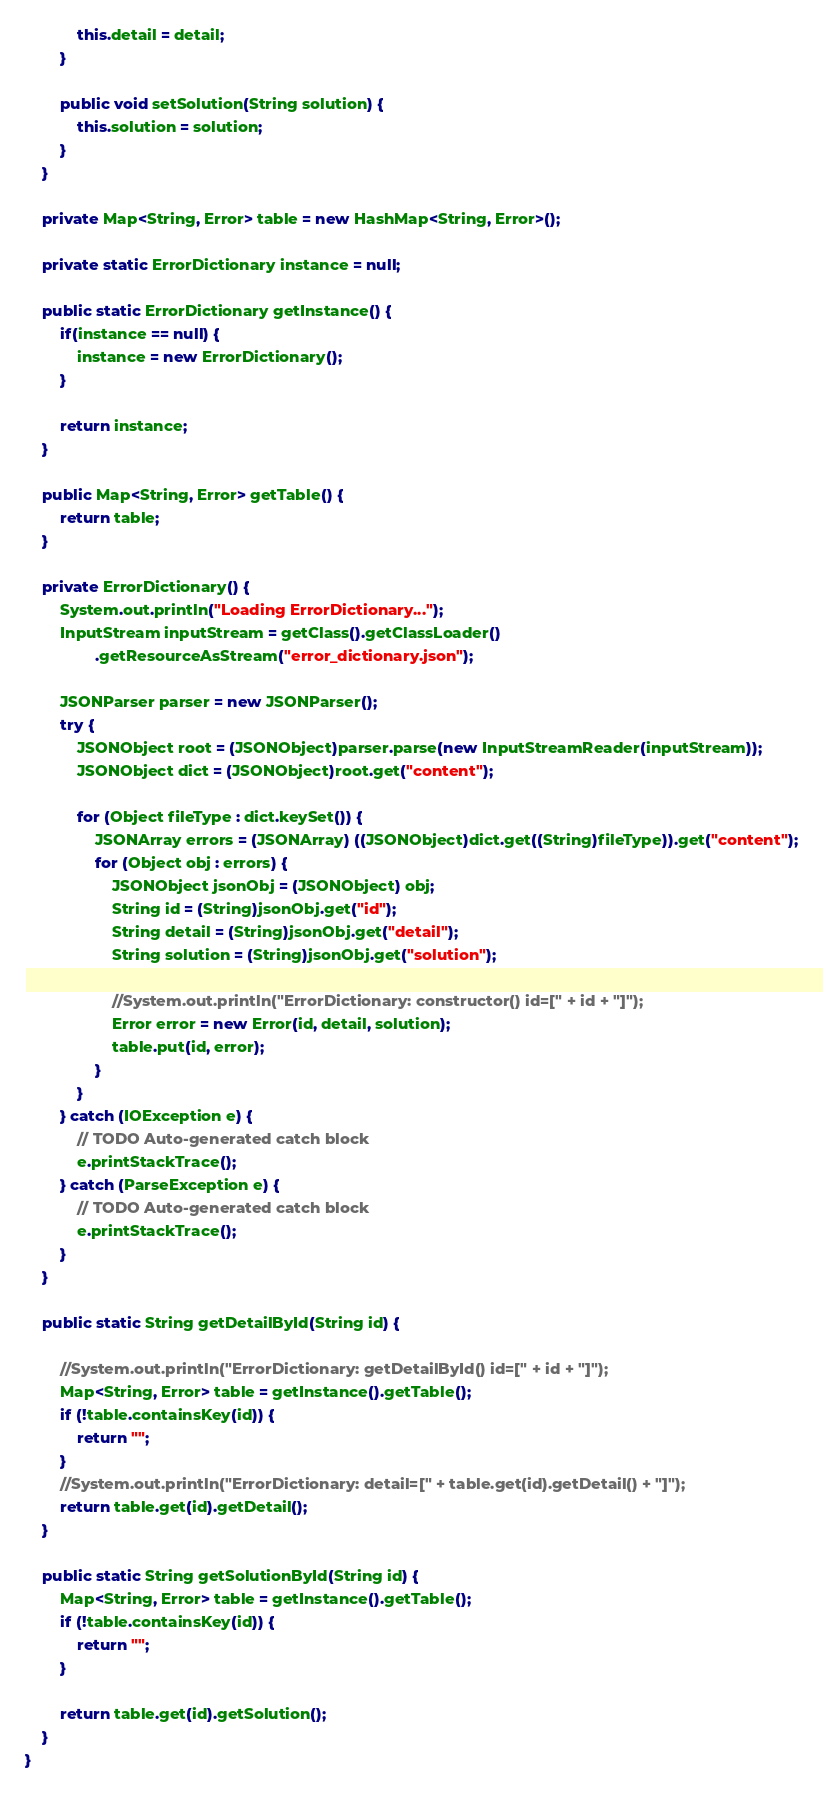<code> <loc_0><loc_0><loc_500><loc_500><_Java_>            this.detail = detail;
        }

        public void setSolution(String solution) {
            this.solution = solution;
        }
    }

    private Map<String, Error> table = new HashMap<String, Error>();

    private static ErrorDictionary instance = null;

    public static ErrorDictionary getInstance() {
        if(instance == null) {
            instance = new ErrorDictionary();
        }

        return instance;
    }

    public Map<String, Error> getTable() {
        return table;
    }

    private ErrorDictionary() {
        System.out.println("Loading ErrorDictionary...");
        InputStream inputStream = getClass().getClassLoader()
                .getResourceAsStream("error_dictionary.json");

        JSONParser parser = new JSONParser();
        try {
            JSONObject root = (JSONObject)parser.parse(new InputStreamReader(inputStream));
            JSONObject dict = (JSONObject)root.get("content");

            for (Object fileType : dict.keySet()) {
                JSONArray errors = (JSONArray) ((JSONObject)dict.get((String)fileType)).get("content");
                for (Object obj : errors) {
                    JSONObject jsonObj = (JSONObject) obj;
                    String id = (String)jsonObj.get("id");
                    String detail = (String)jsonObj.get("detail");
                    String solution = (String)jsonObj.get("solution");

                    //System.out.println("ErrorDictionary: constructor() id=[" + id + "]");
                    Error error = new Error(id, detail, solution);
                    table.put(id, error);
                }
            }
        } catch (IOException e) {
            // TODO Auto-generated catch block
            e.printStackTrace();
        } catch (ParseException e) {
            // TODO Auto-generated catch block
            e.printStackTrace();
        }
    }

    public static String getDetailById(String id) {

        //System.out.println("ErrorDictionary: getDetailById() id=[" + id + "]");
        Map<String, Error> table = getInstance().getTable();
        if (!table.containsKey(id)) {
            return "";
        }
        //System.out.println("ErrorDictionary: detail=[" + table.get(id).getDetail() + "]");
        return table.get(id).getDetail();
    }

    public static String getSolutionById(String id) {
        Map<String, Error> table = getInstance().getTable();
        if (!table.containsKey(id)) {
            return "";
        }

        return table.get(id).getSolution();
    }
}
</code> 